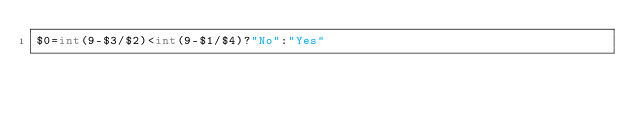Convert code to text. <code><loc_0><loc_0><loc_500><loc_500><_Awk_>$0=int(9-$3/$2)<int(9-$1/$4)?"No":"Yes"</code> 